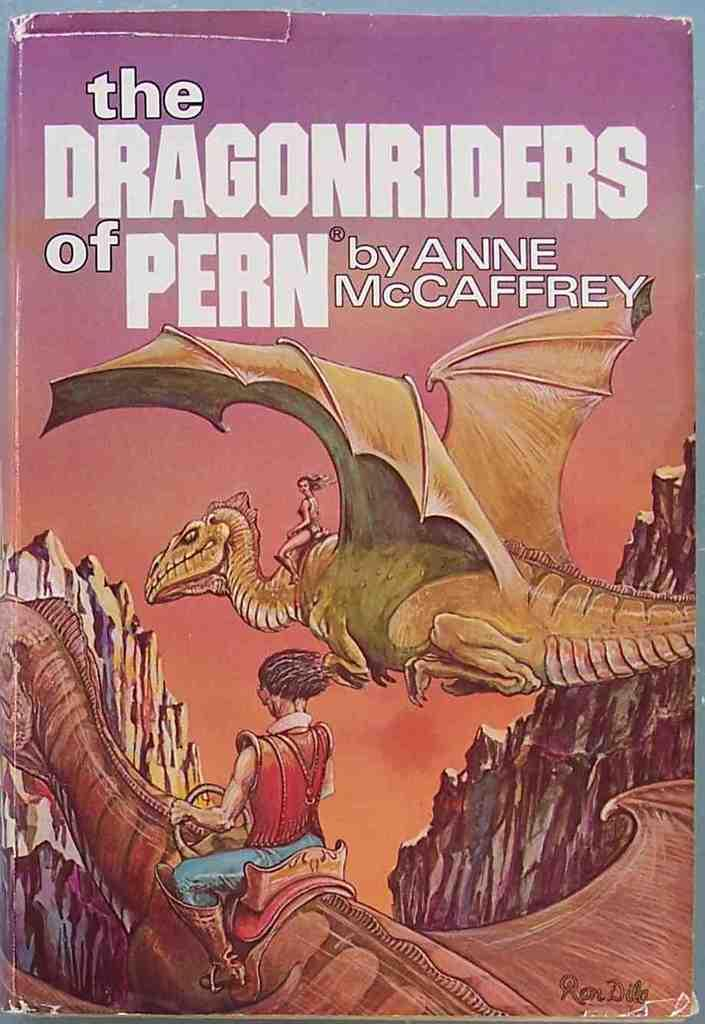<image>
Relay a brief, clear account of the picture shown. A book with a dragon on the front is titled The Dragonriders of Pern. 